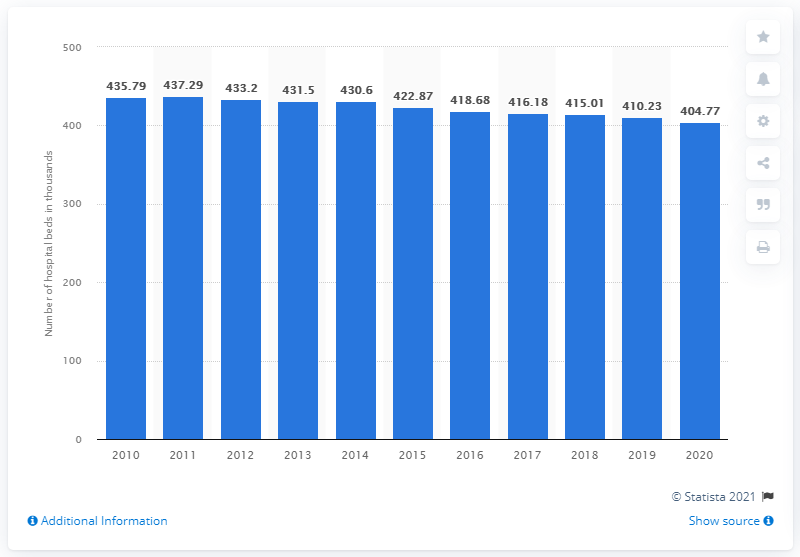Specify some key components in this picture. The number of hospital beds in Brazil has been decreasing since 2011. 